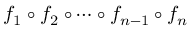<formula> <loc_0><loc_0><loc_500><loc_500>f _ { 1 } \circ f _ { 2 } \circ \cdots \circ f _ { n - 1 } \circ f _ { n }</formula> 